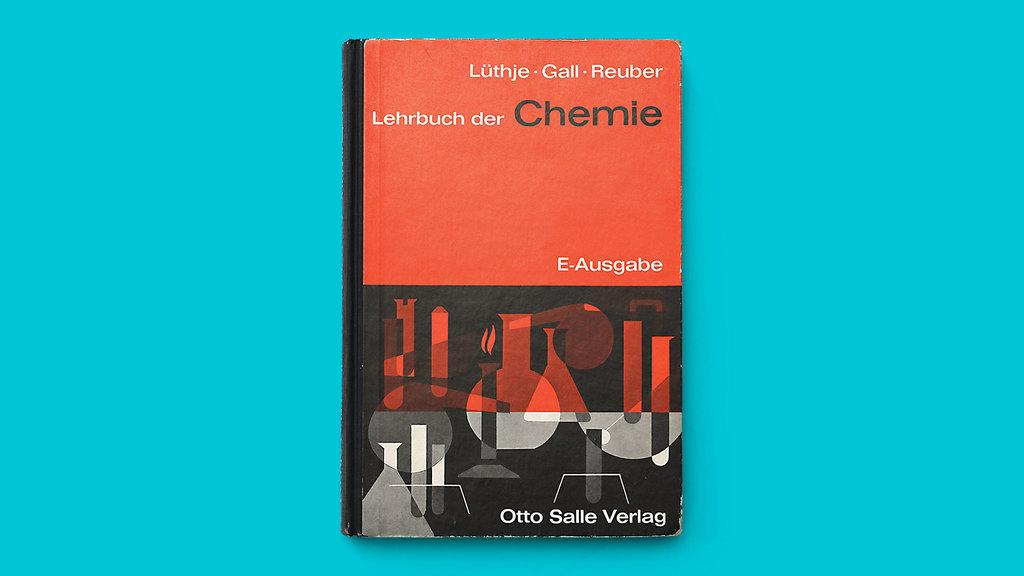<image>
Share a concise interpretation of the image provided. The cover of the book titled Chemie written by Otto Salle Verlag. 